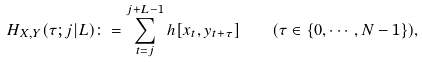<formula> <loc_0><loc_0><loc_500><loc_500>H _ { X , Y } ( \tau ; j | L ) \colon = \sum _ { t = j } ^ { j + L - 1 } h [ x _ { t } , y _ { t + \tau } ] \quad ( \tau \in \{ 0 , \cdots , N - 1 \} ) ,</formula> 